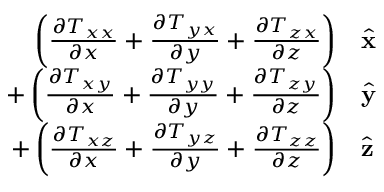Convert formula to latex. <formula><loc_0><loc_0><loc_500><loc_500>\begin{array} { r l } { \left ( { \frac { \partial T _ { x x } } { \partial x } } + { \frac { \partial T _ { y x } } { \partial y } } + { \frac { \partial T _ { z x } } { \partial z } } \right ) } & { \hat { x } } } \\ { + \left ( { \frac { \partial T _ { x y } } { \partial x } } + { \frac { \partial T _ { y y } } { \partial y } } + { \frac { \partial T _ { z y } } { \partial z } } \right ) } & { \hat { y } } } \\ { + \left ( { \frac { \partial T _ { x z } } { \partial x } } + { \frac { \partial T _ { y z } } { \partial y } } + { \frac { \partial T _ { z z } } { \partial z } } \right ) } & { \hat { z } } } \end{array}</formula> 